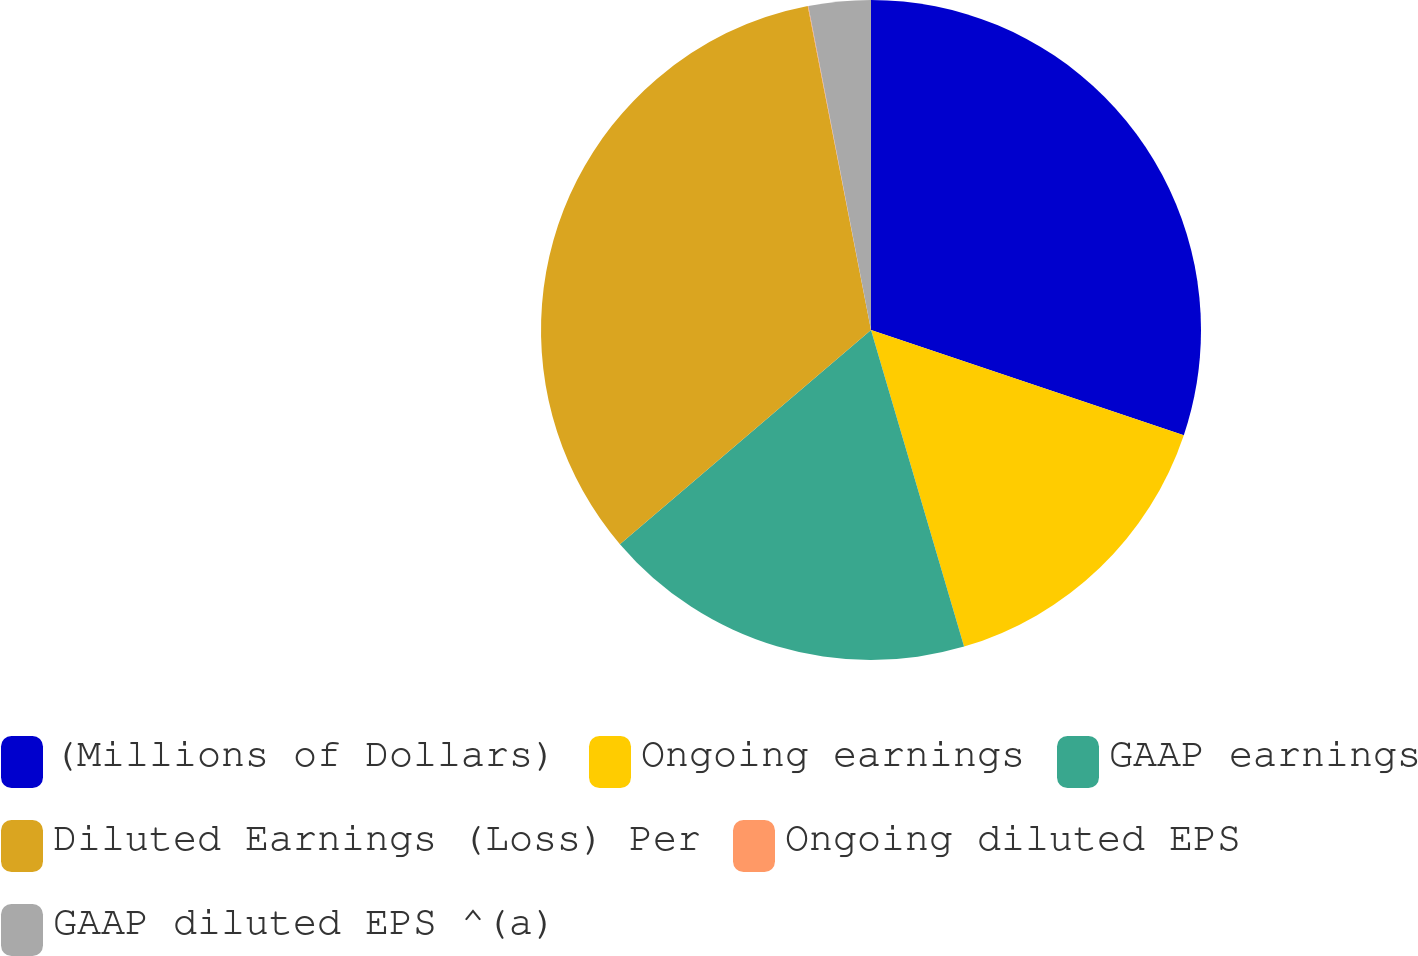Convert chart. <chart><loc_0><loc_0><loc_500><loc_500><pie_chart><fcel>(Millions of Dollars)<fcel>Ongoing earnings<fcel>GAAP earnings<fcel>Diluted Earnings (Loss) Per<fcel>Ongoing diluted EPS<fcel>GAAP diluted EPS ^(a)<nl><fcel>30.16%<fcel>15.29%<fcel>18.31%<fcel>33.17%<fcel>0.03%<fcel>3.04%<nl></chart> 